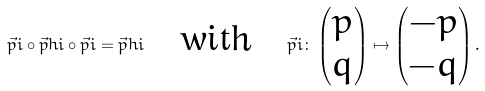<formula> <loc_0><loc_0><loc_500><loc_500>\vec { p } i \circ \vec { p } h i \circ \vec { p } i = \vec { p } h i \quad \text {with} \quad \vec { p } i \colon \begin{pmatrix} p \\ q \end{pmatrix} \mapsto \begin{pmatrix} - p \\ - q \end{pmatrix} .</formula> 